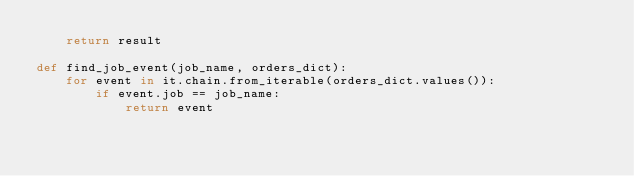Convert code to text. <code><loc_0><loc_0><loc_500><loc_500><_Python_>    return result

def find_job_event(job_name, orders_dict):
    for event in it.chain.from_iterable(orders_dict.values()):
        if event.job == job_name:
            return event
</code> 